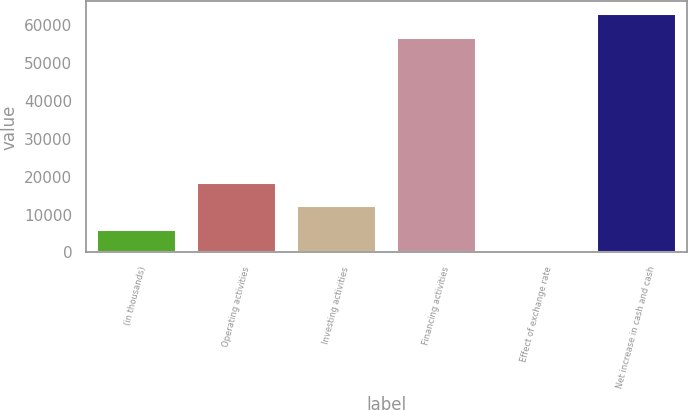Convert chart to OTSL. <chart><loc_0><loc_0><loc_500><loc_500><bar_chart><fcel>(in thousands)<fcel>Operating activities<fcel>Investing activities<fcel>Financing activities<fcel>Effect of exchange rate<fcel>Net increase in cash and cash<nl><fcel>6242.3<fcel>18608.9<fcel>12425.6<fcel>56989<fcel>59<fcel>63172.3<nl></chart> 